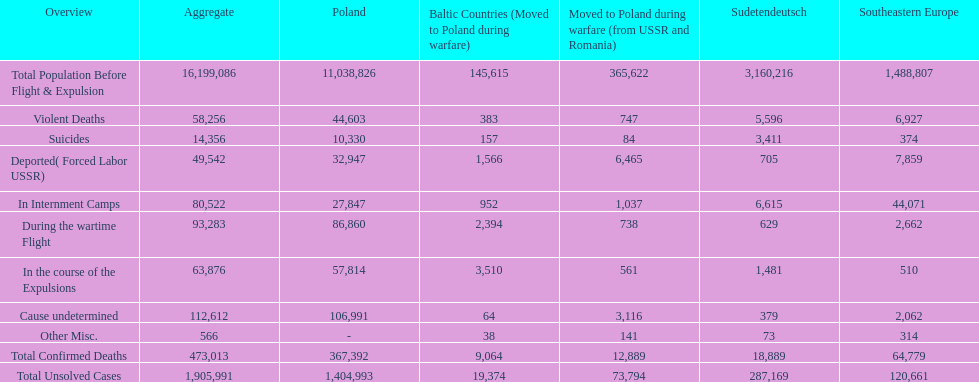What was the cause of the most deaths? Cause undetermined. 